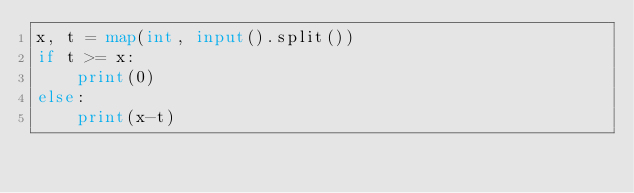Convert code to text. <code><loc_0><loc_0><loc_500><loc_500><_Python_>x, t = map(int, input().split())
if t >= x:
    print(0)
else:
    print(x-t)
</code> 